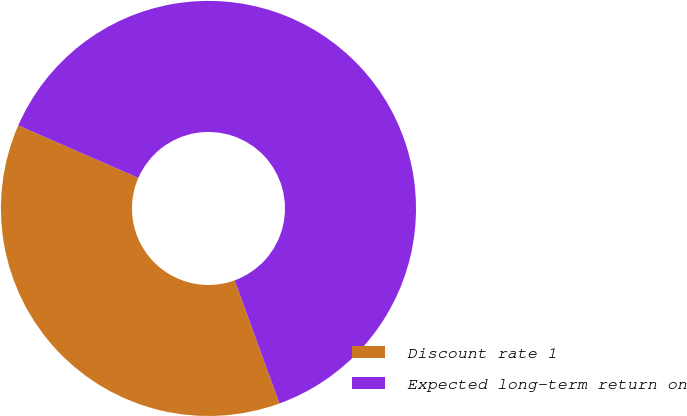Convert chart. <chart><loc_0><loc_0><loc_500><loc_500><pie_chart><fcel>Discount rate 1<fcel>Expected long-term return on<nl><fcel>37.11%<fcel>62.89%<nl></chart> 